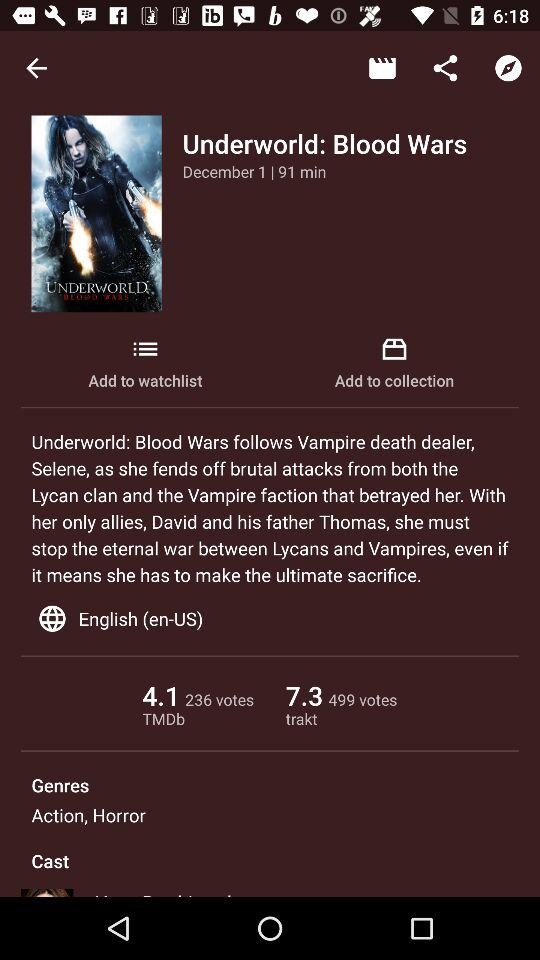What language is shown? The language shown is English (en-US). 